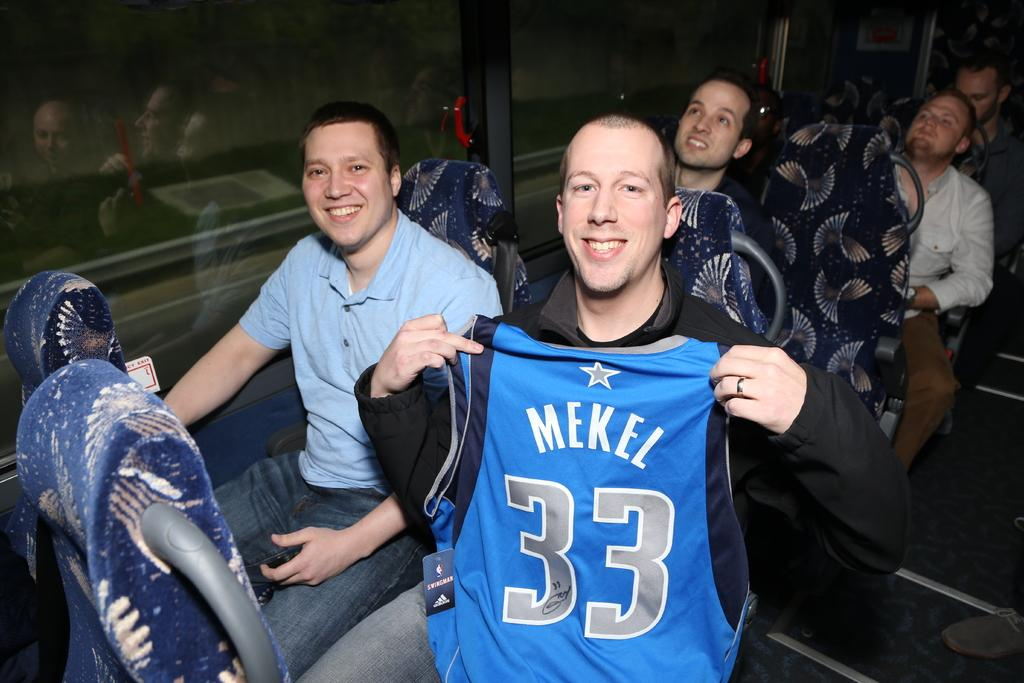What type of vehicle is shown in the image? The image shows an inside view of a bus. What are the men in the image doing? The men are sitting on chairs in the bus. What is the facial expression of the men? The men are smiling. What can be seen through the windows beside the men? There are glass windows beside the men. What type of judgment is the judge making in the image? There is no judge present in the image, as it shows an inside view of a bus with men sitting on chairs. 